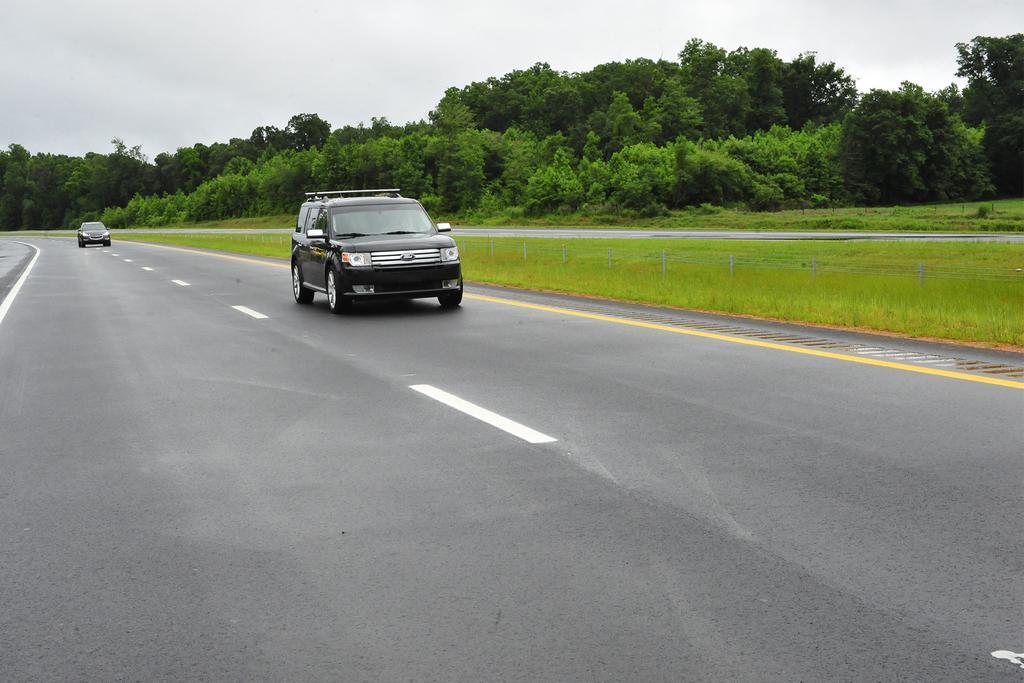How would you summarize this image in a sentence or two? In this image we can able to see two vehicles on the road, there are some trees, plants, and grass on the ground, also we can see the sky. 